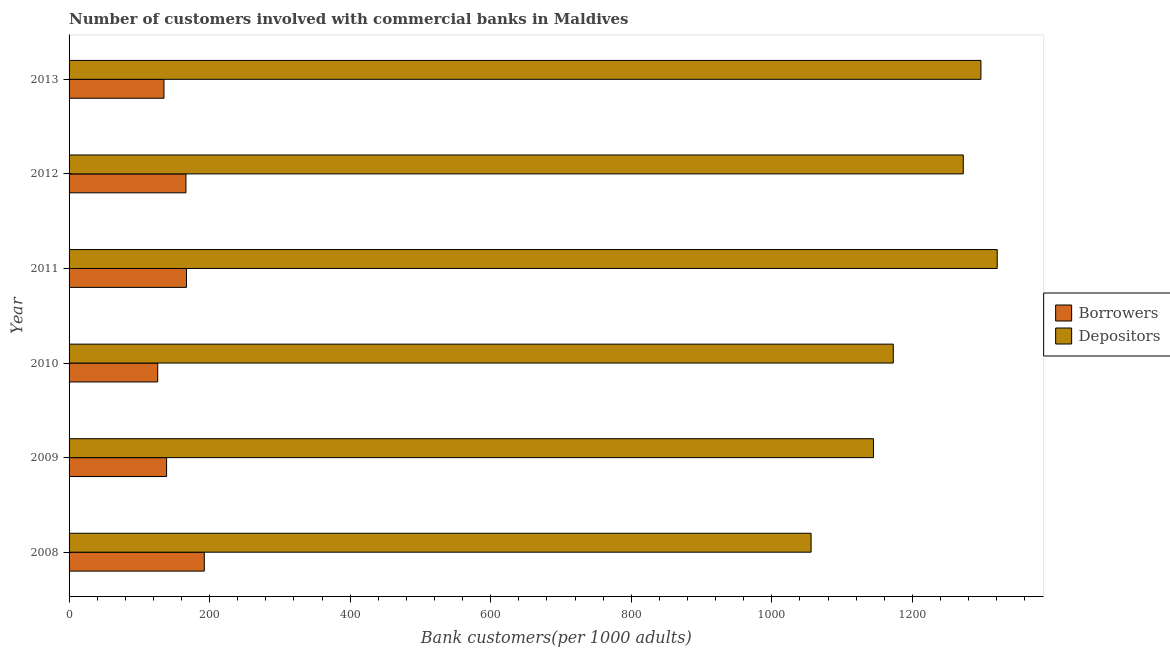How many bars are there on the 6th tick from the bottom?
Provide a short and direct response. 2. What is the number of borrowers in 2008?
Your response must be concise. 192.42. Across all years, what is the maximum number of depositors?
Your response must be concise. 1320.69. Across all years, what is the minimum number of borrowers?
Make the answer very short. 126.14. What is the total number of depositors in the graph?
Provide a short and direct response. 7263.75. What is the difference between the number of borrowers in 2009 and that in 2013?
Give a very brief answer. 3.73. What is the difference between the number of borrowers in 2012 and the number of depositors in 2013?
Keep it short and to the point. -1131.19. What is the average number of borrowers per year?
Provide a succinct answer. 154.29. In the year 2008, what is the difference between the number of borrowers and number of depositors?
Offer a terse response. -863.42. In how many years, is the number of borrowers greater than 1000 ?
Your answer should be very brief. 0. What is the ratio of the number of borrowers in 2009 to that in 2010?
Give a very brief answer. 1.1. Is the number of depositors in 2009 less than that in 2013?
Your answer should be compact. Yes. What is the difference between the highest and the second highest number of depositors?
Provide a succinct answer. 23.21. What is the difference between the highest and the lowest number of depositors?
Make the answer very short. 264.85. In how many years, is the number of depositors greater than the average number of depositors taken over all years?
Offer a terse response. 3. What does the 2nd bar from the top in 2008 represents?
Your answer should be compact. Borrowers. What does the 2nd bar from the bottom in 2009 represents?
Your answer should be very brief. Depositors. How many bars are there?
Make the answer very short. 12. Are all the bars in the graph horizontal?
Give a very brief answer. Yes. What is the difference between two consecutive major ticks on the X-axis?
Your answer should be very brief. 200. Are the values on the major ticks of X-axis written in scientific E-notation?
Offer a terse response. No. Does the graph contain any zero values?
Your answer should be compact. No. Where does the legend appear in the graph?
Your answer should be compact. Center right. How are the legend labels stacked?
Provide a short and direct response. Vertical. What is the title of the graph?
Provide a succinct answer. Number of customers involved with commercial banks in Maldives. What is the label or title of the X-axis?
Provide a succinct answer. Bank customers(per 1000 adults). What is the label or title of the Y-axis?
Provide a succinct answer. Year. What is the Bank customers(per 1000 adults) of Borrowers in 2008?
Ensure brevity in your answer.  192.42. What is the Bank customers(per 1000 adults) in Depositors in 2008?
Your answer should be very brief. 1055.84. What is the Bank customers(per 1000 adults) in Borrowers in 2009?
Provide a succinct answer. 138.77. What is the Bank customers(per 1000 adults) of Depositors in 2009?
Offer a very short reply. 1144.57. What is the Bank customers(per 1000 adults) of Borrowers in 2010?
Your answer should be very brief. 126.14. What is the Bank customers(per 1000 adults) of Depositors in 2010?
Offer a terse response. 1172.79. What is the Bank customers(per 1000 adults) of Borrowers in 2011?
Provide a short and direct response. 167.07. What is the Bank customers(per 1000 adults) in Depositors in 2011?
Keep it short and to the point. 1320.69. What is the Bank customers(per 1000 adults) of Borrowers in 2012?
Provide a short and direct response. 166.29. What is the Bank customers(per 1000 adults) in Depositors in 2012?
Offer a terse response. 1272.39. What is the Bank customers(per 1000 adults) of Borrowers in 2013?
Make the answer very short. 135.04. What is the Bank customers(per 1000 adults) in Depositors in 2013?
Provide a short and direct response. 1297.48. Across all years, what is the maximum Bank customers(per 1000 adults) of Borrowers?
Provide a short and direct response. 192.42. Across all years, what is the maximum Bank customers(per 1000 adults) in Depositors?
Make the answer very short. 1320.69. Across all years, what is the minimum Bank customers(per 1000 adults) in Borrowers?
Your response must be concise. 126.14. Across all years, what is the minimum Bank customers(per 1000 adults) in Depositors?
Provide a short and direct response. 1055.84. What is the total Bank customers(per 1000 adults) in Borrowers in the graph?
Your answer should be very brief. 925.72. What is the total Bank customers(per 1000 adults) of Depositors in the graph?
Your answer should be very brief. 7263.75. What is the difference between the Bank customers(per 1000 adults) in Borrowers in 2008 and that in 2009?
Your answer should be very brief. 53.66. What is the difference between the Bank customers(per 1000 adults) in Depositors in 2008 and that in 2009?
Your answer should be very brief. -88.73. What is the difference between the Bank customers(per 1000 adults) in Borrowers in 2008 and that in 2010?
Your answer should be very brief. 66.29. What is the difference between the Bank customers(per 1000 adults) in Depositors in 2008 and that in 2010?
Provide a succinct answer. -116.95. What is the difference between the Bank customers(per 1000 adults) in Borrowers in 2008 and that in 2011?
Offer a very short reply. 25.36. What is the difference between the Bank customers(per 1000 adults) of Depositors in 2008 and that in 2011?
Your response must be concise. -264.85. What is the difference between the Bank customers(per 1000 adults) in Borrowers in 2008 and that in 2012?
Give a very brief answer. 26.13. What is the difference between the Bank customers(per 1000 adults) of Depositors in 2008 and that in 2012?
Your answer should be very brief. -216.55. What is the difference between the Bank customers(per 1000 adults) in Borrowers in 2008 and that in 2013?
Your answer should be very brief. 57.38. What is the difference between the Bank customers(per 1000 adults) of Depositors in 2008 and that in 2013?
Your answer should be very brief. -241.64. What is the difference between the Bank customers(per 1000 adults) in Borrowers in 2009 and that in 2010?
Give a very brief answer. 12.63. What is the difference between the Bank customers(per 1000 adults) in Depositors in 2009 and that in 2010?
Your answer should be compact. -28.22. What is the difference between the Bank customers(per 1000 adults) of Borrowers in 2009 and that in 2011?
Offer a terse response. -28.3. What is the difference between the Bank customers(per 1000 adults) of Depositors in 2009 and that in 2011?
Make the answer very short. -176.13. What is the difference between the Bank customers(per 1000 adults) of Borrowers in 2009 and that in 2012?
Offer a very short reply. -27.52. What is the difference between the Bank customers(per 1000 adults) in Depositors in 2009 and that in 2012?
Provide a succinct answer. -127.82. What is the difference between the Bank customers(per 1000 adults) in Borrowers in 2009 and that in 2013?
Keep it short and to the point. 3.73. What is the difference between the Bank customers(per 1000 adults) in Depositors in 2009 and that in 2013?
Provide a succinct answer. -152.92. What is the difference between the Bank customers(per 1000 adults) of Borrowers in 2010 and that in 2011?
Give a very brief answer. -40.93. What is the difference between the Bank customers(per 1000 adults) of Depositors in 2010 and that in 2011?
Offer a terse response. -147.91. What is the difference between the Bank customers(per 1000 adults) of Borrowers in 2010 and that in 2012?
Give a very brief answer. -40.15. What is the difference between the Bank customers(per 1000 adults) in Depositors in 2010 and that in 2012?
Provide a succinct answer. -99.6. What is the difference between the Bank customers(per 1000 adults) of Borrowers in 2010 and that in 2013?
Your response must be concise. -8.9. What is the difference between the Bank customers(per 1000 adults) in Depositors in 2010 and that in 2013?
Give a very brief answer. -124.7. What is the difference between the Bank customers(per 1000 adults) in Borrowers in 2011 and that in 2012?
Offer a terse response. 0.78. What is the difference between the Bank customers(per 1000 adults) of Depositors in 2011 and that in 2012?
Your answer should be compact. 48.3. What is the difference between the Bank customers(per 1000 adults) in Borrowers in 2011 and that in 2013?
Ensure brevity in your answer.  32.03. What is the difference between the Bank customers(per 1000 adults) of Depositors in 2011 and that in 2013?
Provide a succinct answer. 23.21. What is the difference between the Bank customers(per 1000 adults) in Borrowers in 2012 and that in 2013?
Ensure brevity in your answer.  31.25. What is the difference between the Bank customers(per 1000 adults) in Depositors in 2012 and that in 2013?
Provide a short and direct response. -25.1. What is the difference between the Bank customers(per 1000 adults) in Borrowers in 2008 and the Bank customers(per 1000 adults) in Depositors in 2009?
Keep it short and to the point. -952.14. What is the difference between the Bank customers(per 1000 adults) of Borrowers in 2008 and the Bank customers(per 1000 adults) of Depositors in 2010?
Make the answer very short. -980.36. What is the difference between the Bank customers(per 1000 adults) in Borrowers in 2008 and the Bank customers(per 1000 adults) in Depositors in 2011?
Your answer should be compact. -1128.27. What is the difference between the Bank customers(per 1000 adults) of Borrowers in 2008 and the Bank customers(per 1000 adults) of Depositors in 2012?
Provide a short and direct response. -1079.96. What is the difference between the Bank customers(per 1000 adults) in Borrowers in 2008 and the Bank customers(per 1000 adults) in Depositors in 2013?
Your answer should be compact. -1105.06. What is the difference between the Bank customers(per 1000 adults) in Borrowers in 2009 and the Bank customers(per 1000 adults) in Depositors in 2010?
Provide a short and direct response. -1034.02. What is the difference between the Bank customers(per 1000 adults) in Borrowers in 2009 and the Bank customers(per 1000 adults) in Depositors in 2011?
Your answer should be compact. -1181.92. What is the difference between the Bank customers(per 1000 adults) in Borrowers in 2009 and the Bank customers(per 1000 adults) in Depositors in 2012?
Offer a very short reply. -1133.62. What is the difference between the Bank customers(per 1000 adults) of Borrowers in 2009 and the Bank customers(per 1000 adults) of Depositors in 2013?
Your response must be concise. -1158.72. What is the difference between the Bank customers(per 1000 adults) of Borrowers in 2010 and the Bank customers(per 1000 adults) of Depositors in 2011?
Keep it short and to the point. -1194.55. What is the difference between the Bank customers(per 1000 adults) in Borrowers in 2010 and the Bank customers(per 1000 adults) in Depositors in 2012?
Give a very brief answer. -1146.25. What is the difference between the Bank customers(per 1000 adults) in Borrowers in 2010 and the Bank customers(per 1000 adults) in Depositors in 2013?
Your response must be concise. -1171.35. What is the difference between the Bank customers(per 1000 adults) in Borrowers in 2011 and the Bank customers(per 1000 adults) in Depositors in 2012?
Provide a succinct answer. -1105.32. What is the difference between the Bank customers(per 1000 adults) of Borrowers in 2011 and the Bank customers(per 1000 adults) of Depositors in 2013?
Your answer should be compact. -1130.42. What is the difference between the Bank customers(per 1000 adults) of Borrowers in 2012 and the Bank customers(per 1000 adults) of Depositors in 2013?
Ensure brevity in your answer.  -1131.19. What is the average Bank customers(per 1000 adults) in Borrowers per year?
Provide a short and direct response. 154.29. What is the average Bank customers(per 1000 adults) of Depositors per year?
Provide a succinct answer. 1210.63. In the year 2008, what is the difference between the Bank customers(per 1000 adults) of Borrowers and Bank customers(per 1000 adults) of Depositors?
Keep it short and to the point. -863.42. In the year 2009, what is the difference between the Bank customers(per 1000 adults) in Borrowers and Bank customers(per 1000 adults) in Depositors?
Provide a short and direct response. -1005.8. In the year 2010, what is the difference between the Bank customers(per 1000 adults) in Borrowers and Bank customers(per 1000 adults) in Depositors?
Give a very brief answer. -1046.65. In the year 2011, what is the difference between the Bank customers(per 1000 adults) of Borrowers and Bank customers(per 1000 adults) of Depositors?
Keep it short and to the point. -1153.63. In the year 2012, what is the difference between the Bank customers(per 1000 adults) of Borrowers and Bank customers(per 1000 adults) of Depositors?
Make the answer very short. -1106.1. In the year 2013, what is the difference between the Bank customers(per 1000 adults) in Borrowers and Bank customers(per 1000 adults) in Depositors?
Ensure brevity in your answer.  -1162.45. What is the ratio of the Bank customers(per 1000 adults) in Borrowers in 2008 to that in 2009?
Your answer should be compact. 1.39. What is the ratio of the Bank customers(per 1000 adults) in Depositors in 2008 to that in 2009?
Offer a terse response. 0.92. What is the ratio of the Bank customers(per 1000 adults) of Borrowers in 2008 to that in 2010?
Offer a terse response. 1.53. What is the ratio of the Bank customers(per 1000 adults) of Depositors in 2008 to that in 2010?
Provide a short and direct response. 0.9. What is the ratio of the Bank customers(per 1000 adults) in Borrowers in 2008 to that in 2011?
Provide a short and direct response. 1.15. What is the ratio of the Bank customers(per 1000 adults) of Depositors in 2008 to that in 2011?
Make the answer very short. 0.8. What is the ratio of the Bank customers(per 1000 adults) of Borrowers in 2008 to that in 2012?
Provide a succinct answer. 1.16. What is the ratio of the Bank customers(per 1000 adults) of Depositors in 2008 to that in 2012?
Your answer should be compact. 0.83. What is the ratio of the Bank customers(per 1000 adults) of Borrowers in 2008 to that in 2013?
Offer a terse response. 1.43. What is the ratio of the Bank customers(per 1000 adults) in Depositors in 2008 to that in 2013?
Make the answer very short. 0.81. What is the ratio of the Bank customers(per 1000 adults) of Borrowers in 2009 to that in 2010?
Provide a succinct answer. 1.1. What is the ratio of the Bank customers(per 1000 adults) of Depositors in 2009 to that in 2010?
Keep it short and to the point. 0.98. What is the ratio of the Bank customers(per 1000 adults) in Borrowers in 2009 to that in 2011?
Keep it short and to the point. 0.83. What is the ratio of the Bank customers(per 1000 adults) in Depositors in 2009 to that in 2011?
Ensure brevity in your answer.  0.87. What is the ratio of the Bank customers(per 1000 adults) of Borrowers in 2009 to that in 2012?
Your response must be concise. 0.83. What is the ratio of the Bank customers(per 1000 adults) of Depositors in 2009 to that in 2012?
Ensure brevity in your answer.  0.9. What is the ratio of the Bank customers(per 1000 adults) of Borrowers in 2009 to that in 2013?
Make the answer very short. 1.03. What is the ratio of the Bank customers(per 1000 adults) of Depositors in 2009 to that in 2013?
Offer a very short reply. 0.88. What is the ratio of the Bank customers(per 1000 adults) in Borrowers in 2010 to that in 2011?
Provide a short and direct response. 0.76. What is the ratio of the Bank customers(per 1000 adults) of Depositors in 2010 to that in 2011?
Your answer should be compact. 0.89. What is the ratio of the Bank customers(per 1000 adults) of Borrowers in 2010 to that in 2012?
Offer a very short reply. 0.76. What is the ratio of the Bank customers(per 1000 adults) of Depositors in 2010 to that in 2012?
Ensure brevity in your answer.  0.92. What is the ratio of the Bank customers(per 1000 adults) of Borrowers in 2010 to that in 2013?
Give a very brief answer. 0.93. What is the ratio of the Bank customers(per 1000 adults) in Depositors in 2010 to that in 2013?
Your response must be concise. 0.9. What is the ratio of the Bank customers(per 1000 adults) of Borrowers in 2011 to that in 2012?
Your answer should be very brief. 1. What is the ratio of the Bank customers(per 1000 adults) of Depositors in 2011 to that in 2012?
Your answer should be very brief. 1.04. What is the ratio of the Bank customers(per 1000 adults) of Borrowers in 2011 to that in 2013?
Your answer should be very brief. 1.24. What is the ratio of the Bank customers(per 1000 adults) of Depositors in 2011 to that in 2013?
Your answer should be compact. 1.02. What is the ratio of the Bank customers(per 1000 adults) of Borrowers in 2012 to that in 2013?
Your answer should be compact. 1.23. What is the ratio of the Bank customers(per 1000 adults) of Depositors in 2012 to that in 2013?
Give a very brief answer. 0.98. What is the difference between the highest and the second highest Bank customers(per 1000 adults) of Borrowers?
Give a very brief answer. 25.36. What is the difference between the highest and the second highest Bank customers(per 1000 adults) in Depositors?
Ensure brevity in your answer.  23.21. What is the difference between the highest and the lowest Bank customers(per 1000 adults) in Borrowers?
Make the answer very short. 66.29. What is the difference between the highest and the lowest Bank customers(per 1000 adults) in Depositors?
Provide a succinct answer. 264.85. 